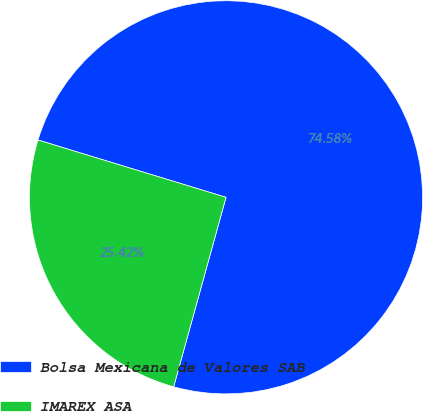Convert chart to OTSL. <chart><loc_0><loc_0><loc_500><loc_500><pie_chart><fcel>Bolsa Mexicana de Valores SAB<fcel>IMAREX ASA<nl><fcel>74.58%<fcel>25.42%<nl></chart> 